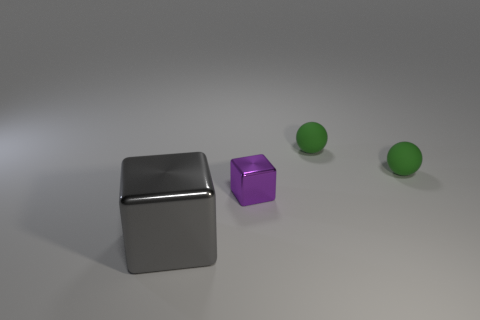Is the number of metal blocks behind the tiny purple metallic object the same as the number of small blocks?
Provide a short and direct response. No. There is a purple shiny thing; are there any small green matte spheres right of it?
Keep it short and to the point. Yes. How many rubber things are purple cubes or balls?
Your answer should be very brief. 2. What number of green spheres are on the right side of the large cube?
Give a very brief answer. 2. Is there a gray object of the same size as the purple object?
Give a very brief answer. No. Are there any other big objects of the same color as the large metallic object?
Keep it short and to the point. No. Is there any other thing that is the same size as the gray cube?
Keep it short and to the point. No. What number of tiny rubber things have the same color as the large cube?
Make the answer very short. 0. Do the tiny shiny cube and the metallic cube in front of the tiny purple metallic block have the same color?
Your answer should be compact. No. What number of things are small green objects or things behind the purple metallic thing?
Your answer should be compact. 2. 